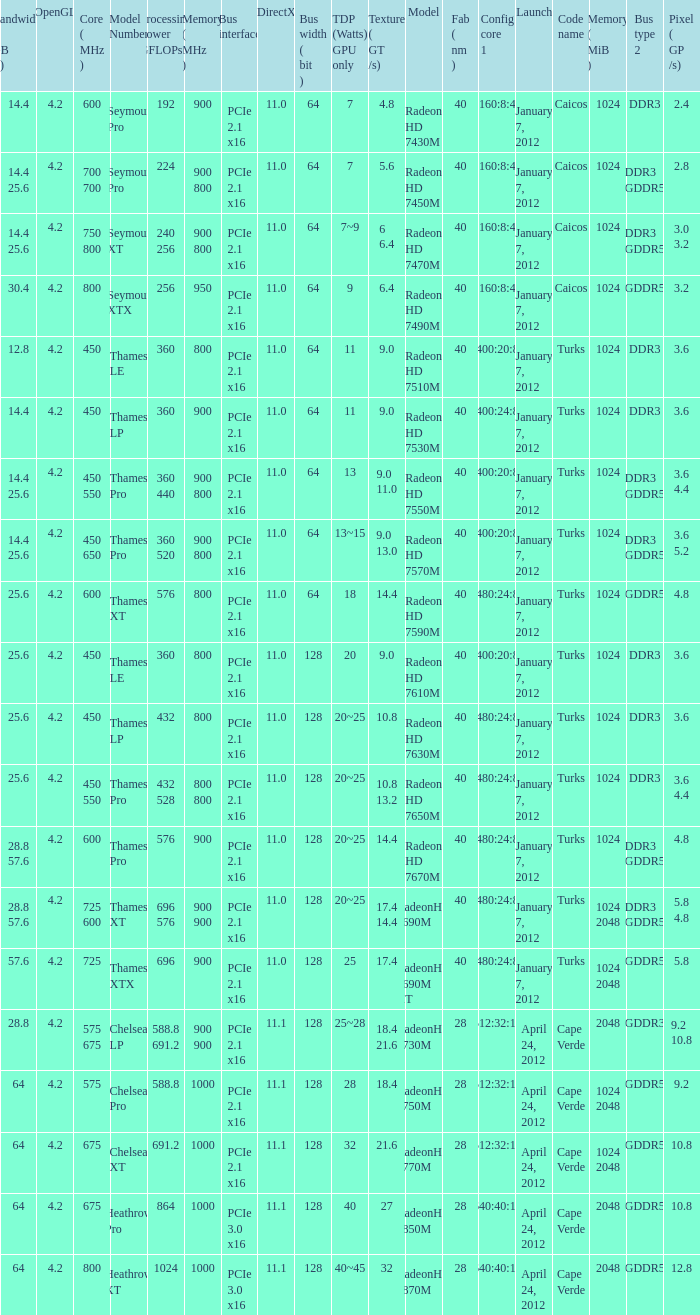How many texture (gt/s) the card has if the tdp (watts) GPU only is 18? 1.0. 